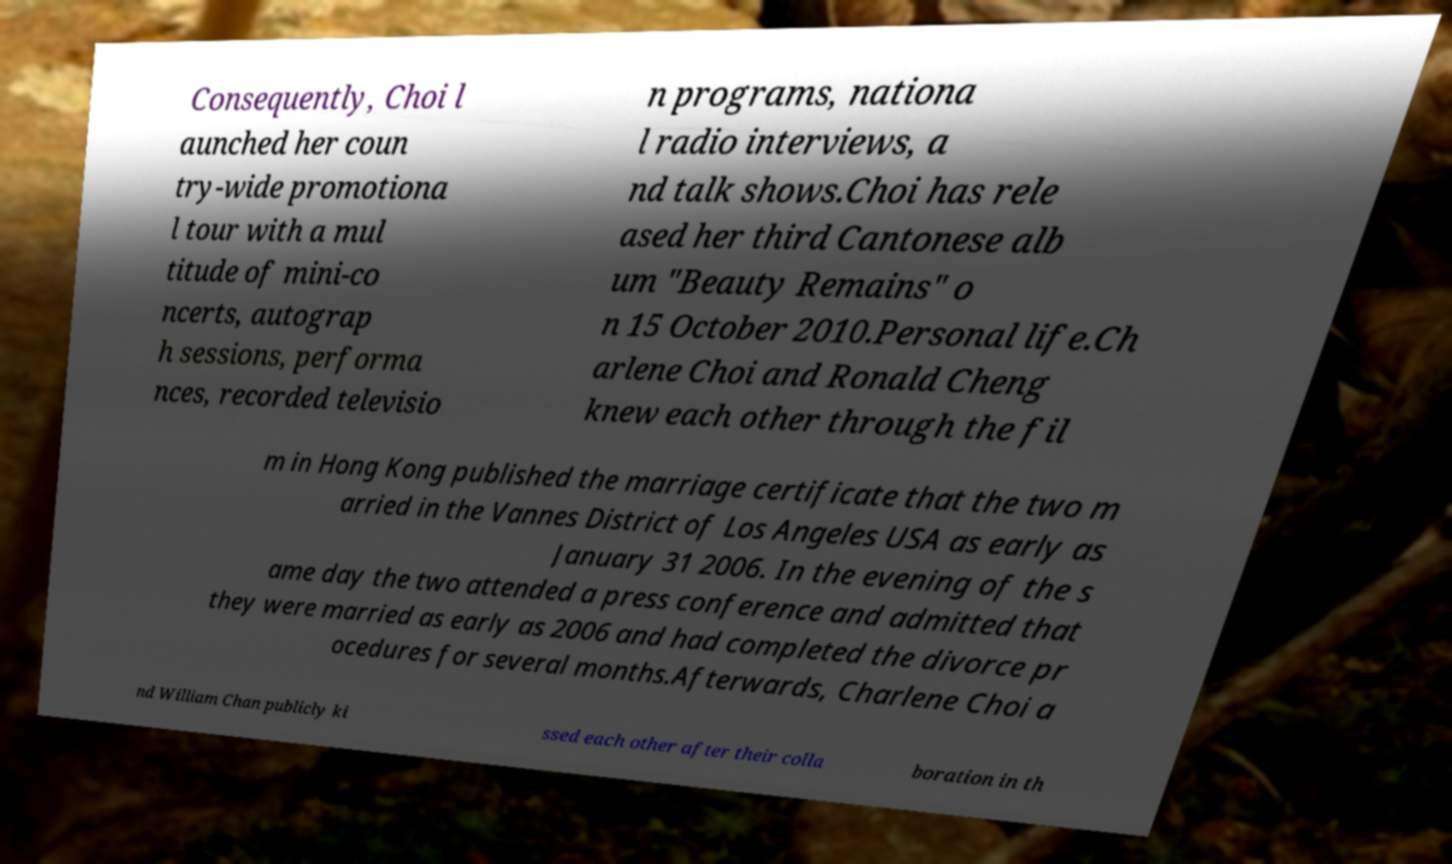For documentation purposes, I need the text within this image transcribed. Could you provide that? Consequently, Choi l aunched her coun try-wide promotiona l tour with a mul titude of mini-co ncerts, autograp h sessions, performa nces, recorded televisio n programs, nationa l radio interviews, a nd talk shows.Choi has rele ased her third Cantonese alb um "Beauty Remains" o n 15 October 2010.Personal life.Ch arlene Choi and Ronald Cheng knew each other through the fil m in Hong Kong published the marriage certificate that the two m arried in the Vannes District of Los Angeles USA as early as January 31 2006. In the evening of the s ame day the two attended a press conference and admitted that they were married as early as 2006 and had completed the divorce pr ocedures for several months.Afterwards, Charlene Choi a nd William Chan publicly ki ssed each other after their colla boration in th 